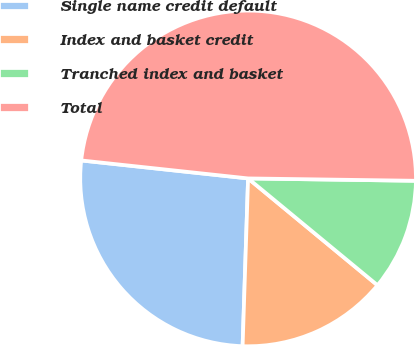<chart> <loc_0><loc_0><loc_500><loc_500><pie_chart><fcel>Single name credit default<fcel>Index and basket credit<fcel>Tranched index and basket<fcel>Total<nl><fcel>26.19%<fcel>14.54%<fcel>10.76%<fcel>48.52%<nl></chart> 